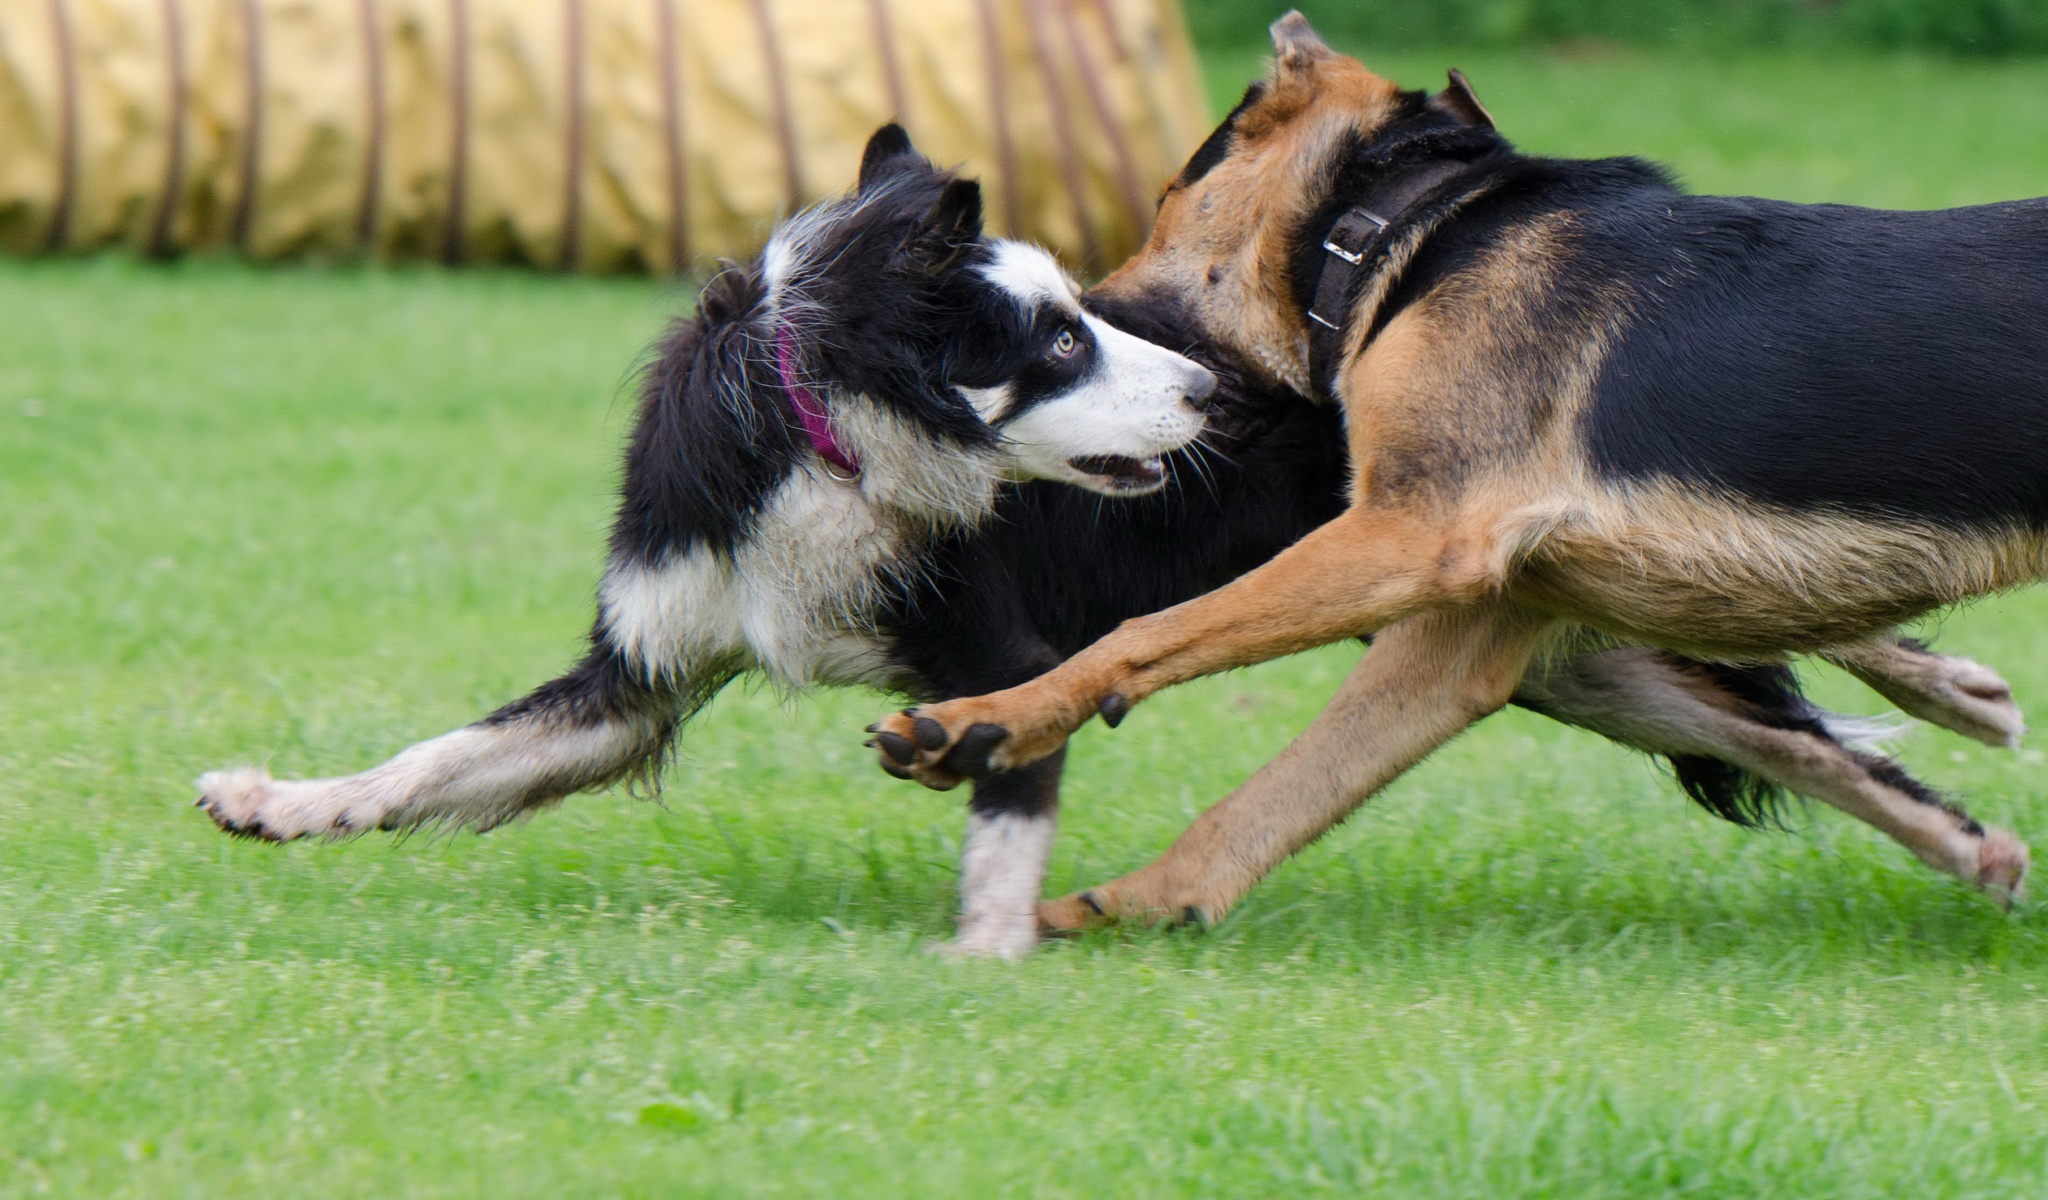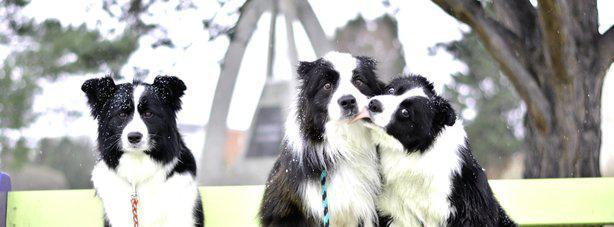The first image is the image on the left, the second image is the image on the right. For the images shown, is this caption "There are at least seven dogs in the image on the right." true? Answer yes or no. No. 